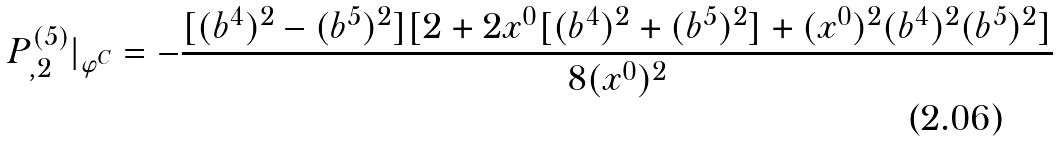Convert formula to latex. <formula><loc_0><loc_0><loc_500><loc_500>P ^ { ( 5 ) } _ { , 2 } | _ { \varphi ^ { C } } = - \frac { [ ( b ^ { 4 } ) ^ { 2 } - ( b ^ { 5 } ) ^ { 2 } ] [ 2 + 2 x ^ { 0 } [ ( b ^ { 4 } ) ^ { 2 } + ( b ^ { 5 } ) ^ { 2 } ] + ( x ^ { 0 } ) ^ { 2 } ( b ^ { 4 } ) ^ { 2 } ( b ^ { 5 } ) ^ { 2 } ] } { 8 ( x ^ { 0 } ) ^ { 2 } }</formula> 